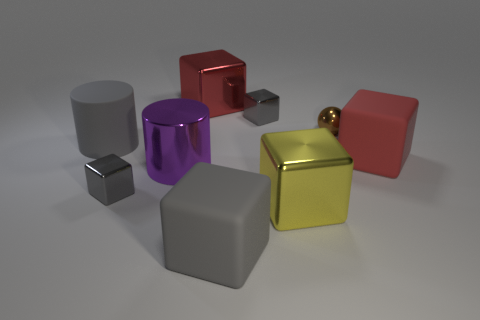There is a rubber object that is the same color as the rubber cylinder; what is its size?
Your answer should be compact. Large. Is there a big green block?
Offer a very short reply. No. There is a big gray thing behind the cylinder to the right of the tiny thing that is to the left of the big gray matte block; what shape is it?
Give a very brief answer. Cylinder. There is a large shiny cylinder; what number of small gray objects are behind it?
Ensure brevity in your answer.  1. Is the big cube that is in front of the large yellow metal object made of the same material as the small brown thing?
Offer a very short reply. No. How many other things are the same shape as the large yellow object?
Keep it short and to the point. 5. How many spheres are in front of the rubber block that is behind the small cube in front of the purple thing?
Make the answer very short. 0. There is a cylinder in front of the big red rubber block; what is its color?
Your response must be concise. Purple. There is a matte cube in front of the big purple metallic object; is its color the same as the tiny ball?
Your answer should be very brief. No. What is the size of the other object that is the same shape as the large purple thing?
Offer a very short reply. Large. 